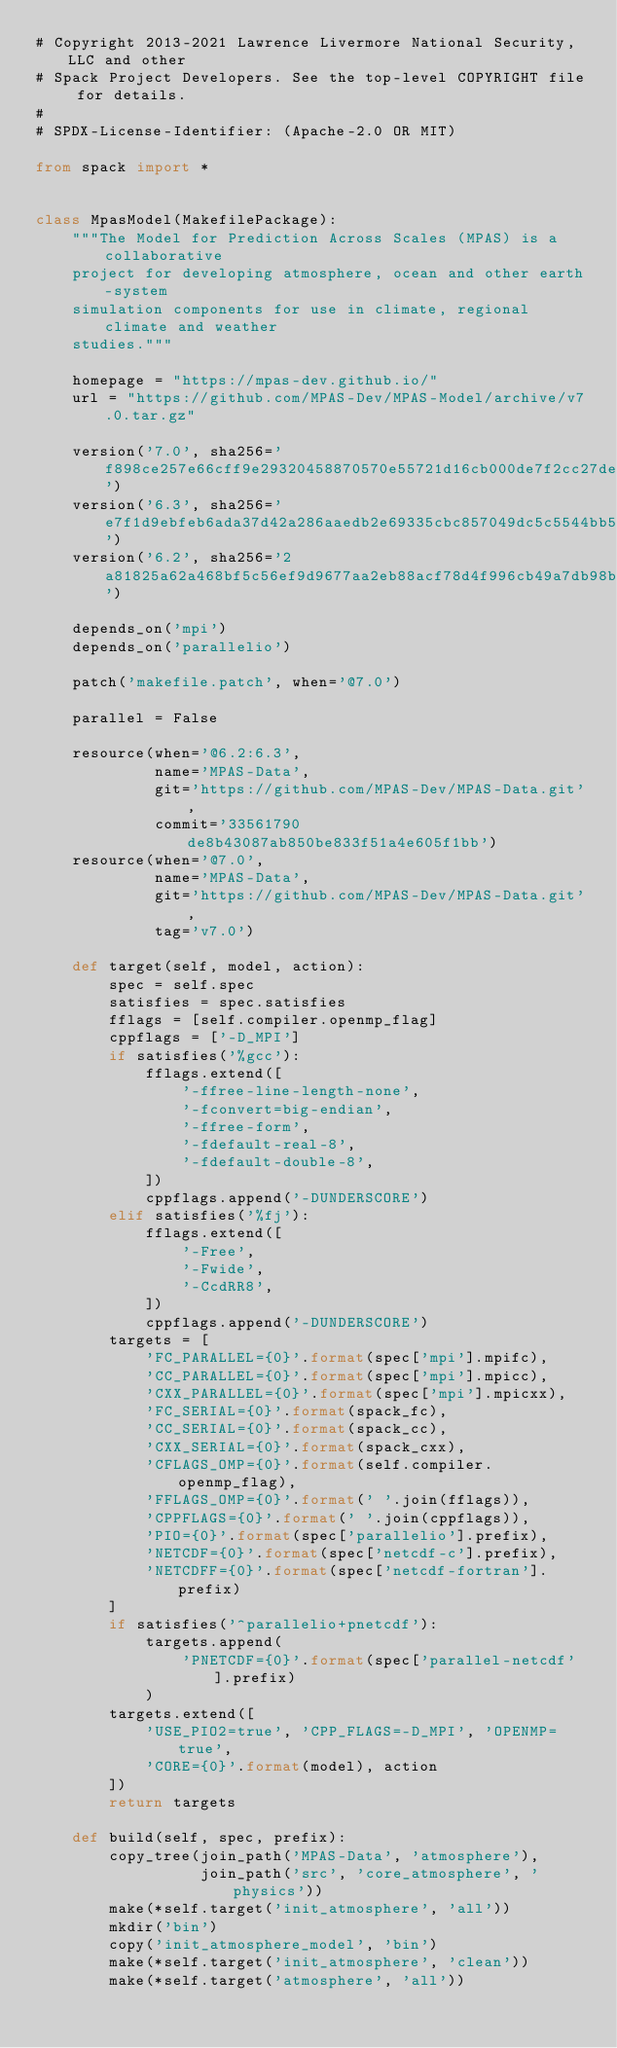Convert code to text. <code><loc_0><loc_0><loc_500><loc_500><_Python_># Copyright 2013-2021 Lawrence Livermore National Security, LLC and other
# Spack Project Developers. See the top-level COPYRIGHT file for details.
#
# SPDX-License-Identifier: (Apache-2.0 OR MIT)

from spack import *


class MpasModel(MakefilePackage):
    """The Model for Prediction Across Scales (MPAS) is a collaborative
    project for developing atmosphere, ocean and other earth-system
    simulation components for use in climate, regional climate and weather
    studies."""

    homepage = "https://mpas-dev.github.io/"
    url = "https://github.com/MPAS-Dev/MPAS-Model/archive/v7.0.tar.gz"

    version('7.0', sha256='f898ce257e66cff9e29320458870570e55721d16cb000de7f2cc27de7fdef14f')
    version('6.3', sha256='e7f1d9ebfeb6ada37d42a286aaedb2e69335cbc857049dc5c5544bb51e7a8db8')
    version('6.2', sha256='2a81825a62a468bf5c56ef9d9677aa2eb88acf78d4f996cb49a7db98b94a6b16')

    depends_on('mpi')
    depends_on('parallelio')

    patch('makefile.patch', when='@7.0')

    parallel = False

    resource(when='@6.2:6.3',
             name='MPAS-Data',
             git='https://github.com/MPAS-Dev/MPAS-Data.git',
             commit='33561790de8b43087ab850be833f51a4e605f1bb')
    resource(when='@7.0',
             name='MPAS-Data',
             git='https://github.com/MPAS-Dev/MPAS-Data.git',
             tag='v7.0')

    def target(self, model, action):
        spec = self.spec
        satisfies = spec.satisfies
        fflags = [self.compiler.openmp_flag]
        cppflags = ['-D_MPI']
        if satisfies('%gcc'):
            fflags.extend([
                '-ffree-line-length-none',
                '-fconvert=big-endian',
                '-ffree-form',
                '-fdefault-real-8',
                '-fdefault-double-8',
            ])
            cppflags.append('-DUNDERSCORE')
        elif satisfies('%fj'):
            fflags.extend([
                '-Free',
                '-Fwide',
                '-CcdRR8',
            ])
            cppflags.append('-DUNDERSCORE')
        targets = [
            'FC_PARALLEL={0}'.format(spec['mpi'].mpifc),
            'CC_PARALLEL={0}'.format(spec['mpi'].mpicc),
            'CXX_PARALLEL={0}'.format(spec['mpi'].mpicxx),
            'FC_SERIAL={0}'.format(spack_fc),
            'CC_SERIAL={0}'.format(spack_cc),
            'CXX_SERIAL={0}'.format(spack_cxx),
            'CFLAGS_OMP={0}'.format(self.compiler.openmp_flag),
            'FFLAGS_OMP={0}'.format(' '.join(fflags)),
            'CPPFLAGS={0}'.format(' '.join(cppflags)),
            'PIO={0}'.format(spec['parallelio'].prefix),
            'NETCDF={0}'.format(spec['netcdf-c'].prefix),
            'NETCDFF={0}'.format(spec['netcdf-fortran'].prefix)
        ]
        if satisfies('^parallelio+pnetcdf'):
            targets.append(
                'PNETCDF={0}'.format(spec['parallel-netcdf'].prefix)
            )
        targets.extend([
            'USE_PIO2=true', 'CPP_FLAGS=-D_MPI', 'OPENMP=true',
            'CORE={0}'.format(model), action
        ])
        return targets

    def build(self, spec, prefix):
        copy_tree(join_path('MPAS-Data', 'atmosphere'),
                  join_path('src', 'core_atmosphere', 'physics'))
        make(*self.target('init_atmosphere', 'all'))
        mkdir('bin')
        copy('init_atmosphere_model', 'bin')
        make(*self.target('init_atmosphere', 'clean'))
        make(*self.target('atmosphere', 'all'))</code> 